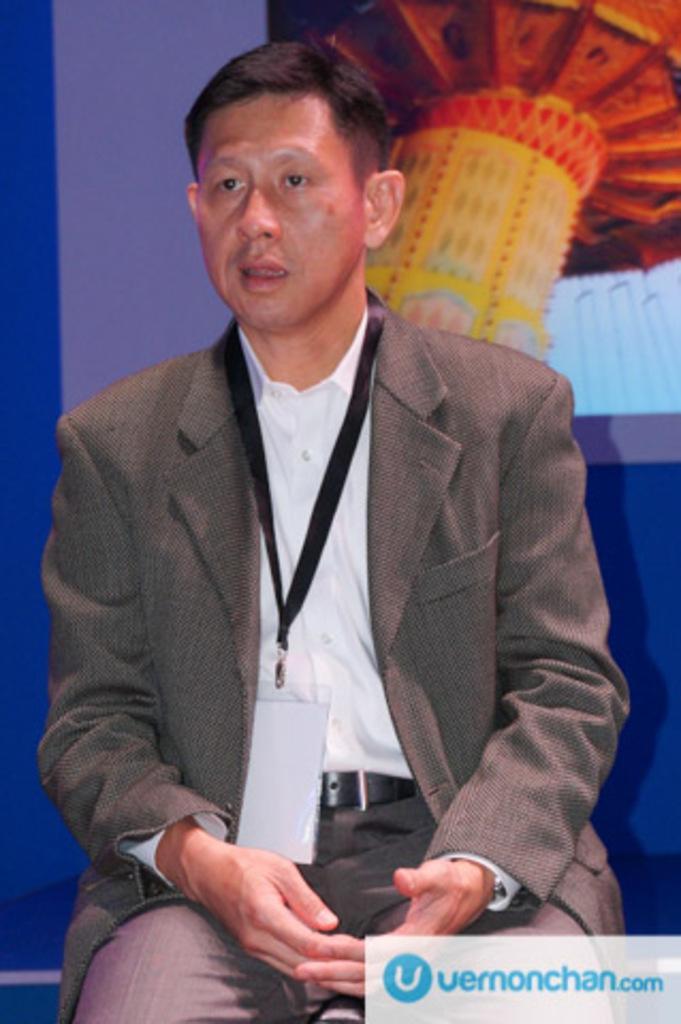Can you describe this image briefly? In this image I can see a person sitting on sofa set and I can see a colorful background in the image 